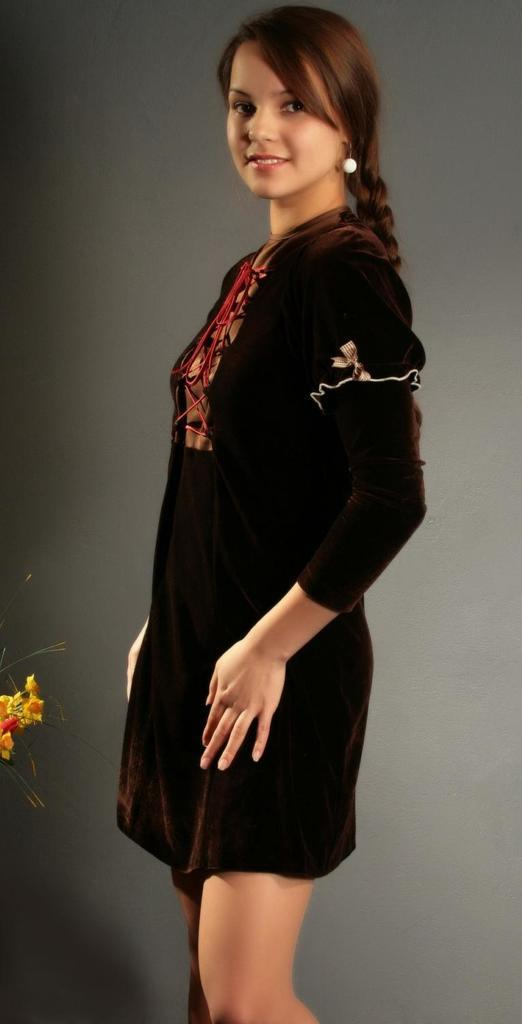Who is present in the image? There is a woman in the image. What is the woman doing in the image? The woman is standing. What is the woman wearing in the image? The woman is wearing a black dress. What colors are present in the background of the image? The background of the image is in grey and black colors. What type of object can be seen in the image? There is a yellow flower in the image. What is the chance of the woman winning a prize at the farm in the image? There is no farm present in the image, and therefore no context for the woman to win a prize. 